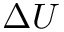Convert formula to latex. <formula><loc_0><loc_0><loc_500><loc_500>\Delta U</formula> 